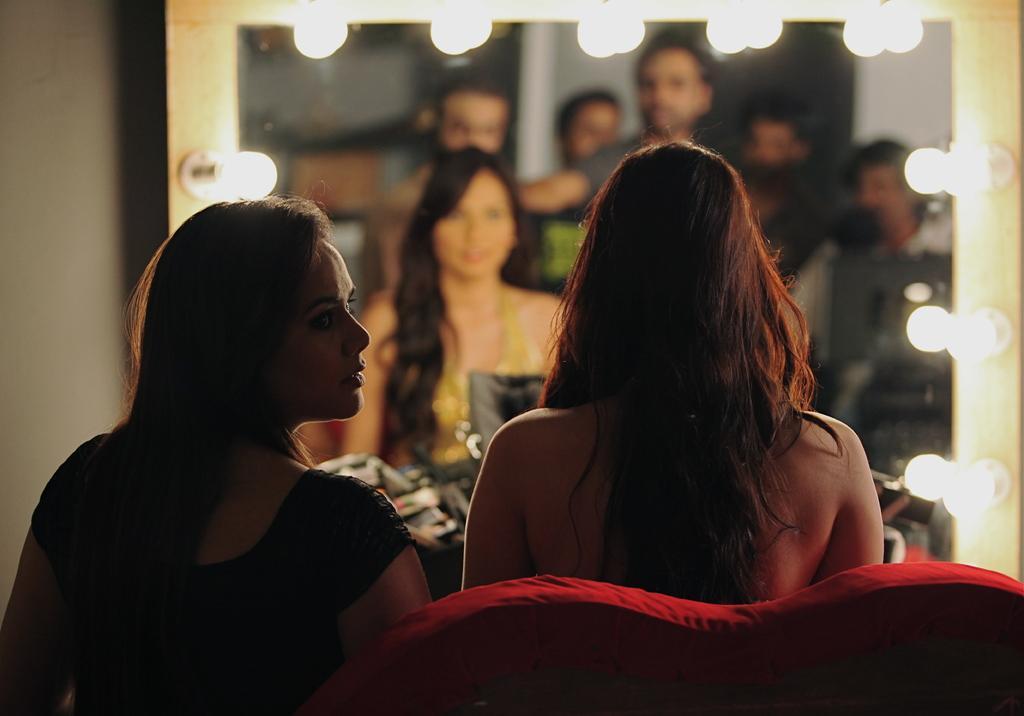How would you summarize this image in a sentence or two? In this picture couple of them seated on the sofa and we see a mirror and i can see reflection of people standing and lights around the frame. 